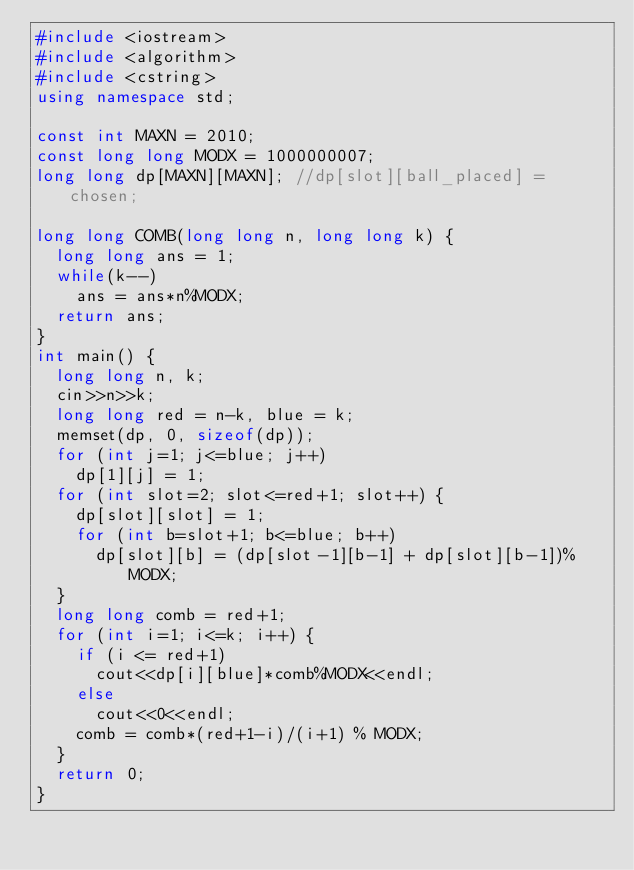<code> <loc_0><loc_0><loc_500><loc_500><_C++_>#include <iostream>
#include <algorithm>
#include <cstring>
using namespace std;

const int MAXN = 2010;
const long long MODX = 1000000007;
long long dp[MAXN][MAXN]; //dp[slot][ball_placed] = chosen;

long long COMB(long long n, long long k) {
	long long ans = 1;
	while(k--)
		ans = ans*n%MODX;
	return ans;
}
int main() {
	long long n, k;
	cin>>n>>k;
	long long red = n-k, blue = k;
	memset(dp, 0, sizeof(dp));
	for (int j=1; j<=blue; j++)
		dp[1][j] = 1;
	for (int slot=2; slot<=red+1; slot++) {
		dp[slot][slot] = 1;
		for (int b=slot+1; b<=blue; b++)
			dp[slot][b] = (dp[slot-1][b-1] + dp[slot][b-1])%MODX;
	}
	long long comb = red+1;
	for (int i=1; i<=k; i++) {
		if (i <= red+1)
			cout<<dp[i][blue]*comb%MODX<<endl;
		else
			cout<<0<<endl;
		comb = comb*(red+1-i)/(i+1) % MODX;
	}
	return 0;
}</code> 